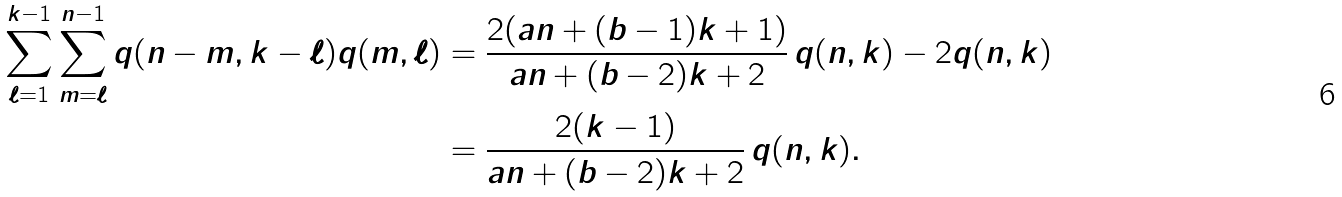Convert formula to latex. <formula><loc_0><loc_0><loc_500><loc_500>\sum _ { \ell = 1 } ^ { k - 1 } \sum _ { m = \ell } ^ { n - 1 } q ( n - m , k - \ell ) q ( m , \ell ) & = \frac { 2 ( a n + ( b - 1 ) k + 1 ) } { a n + ( b - 2 ) k + 2 } \, q ( n , k ) - 2 q ( n , k ) \\ & = \frac { 2 ( k - 1 ) } { a n + ( b - 2 ) k + 2 } \, q ( n , k ) .</formula> 